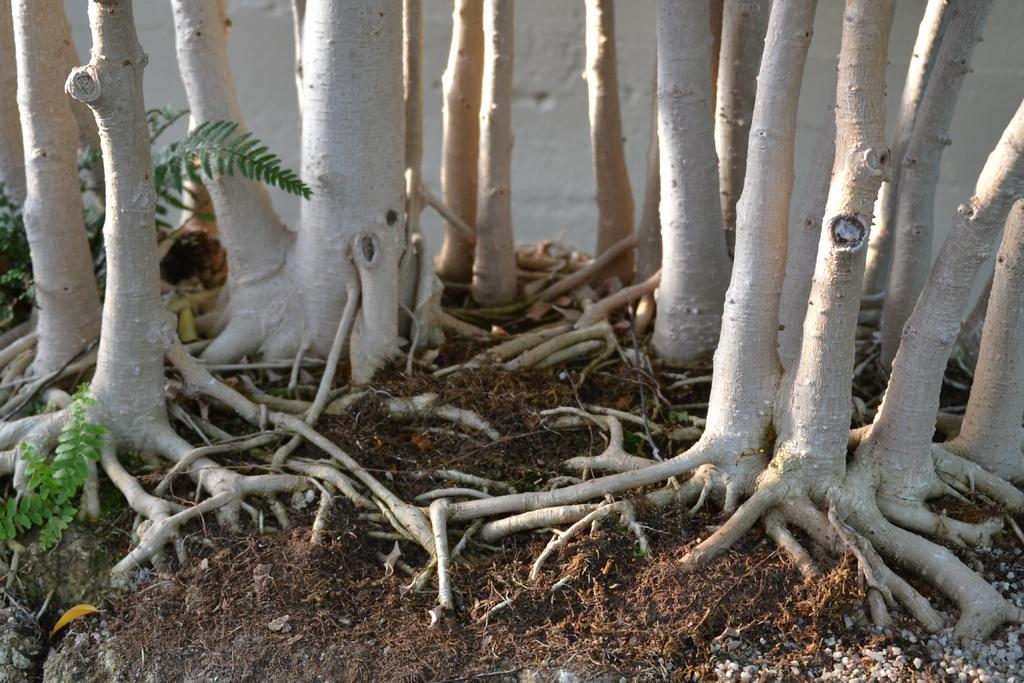How would you summarize this image in a sentence or two? In this image there is a plant, there are roots, there is trunk of the tree. 